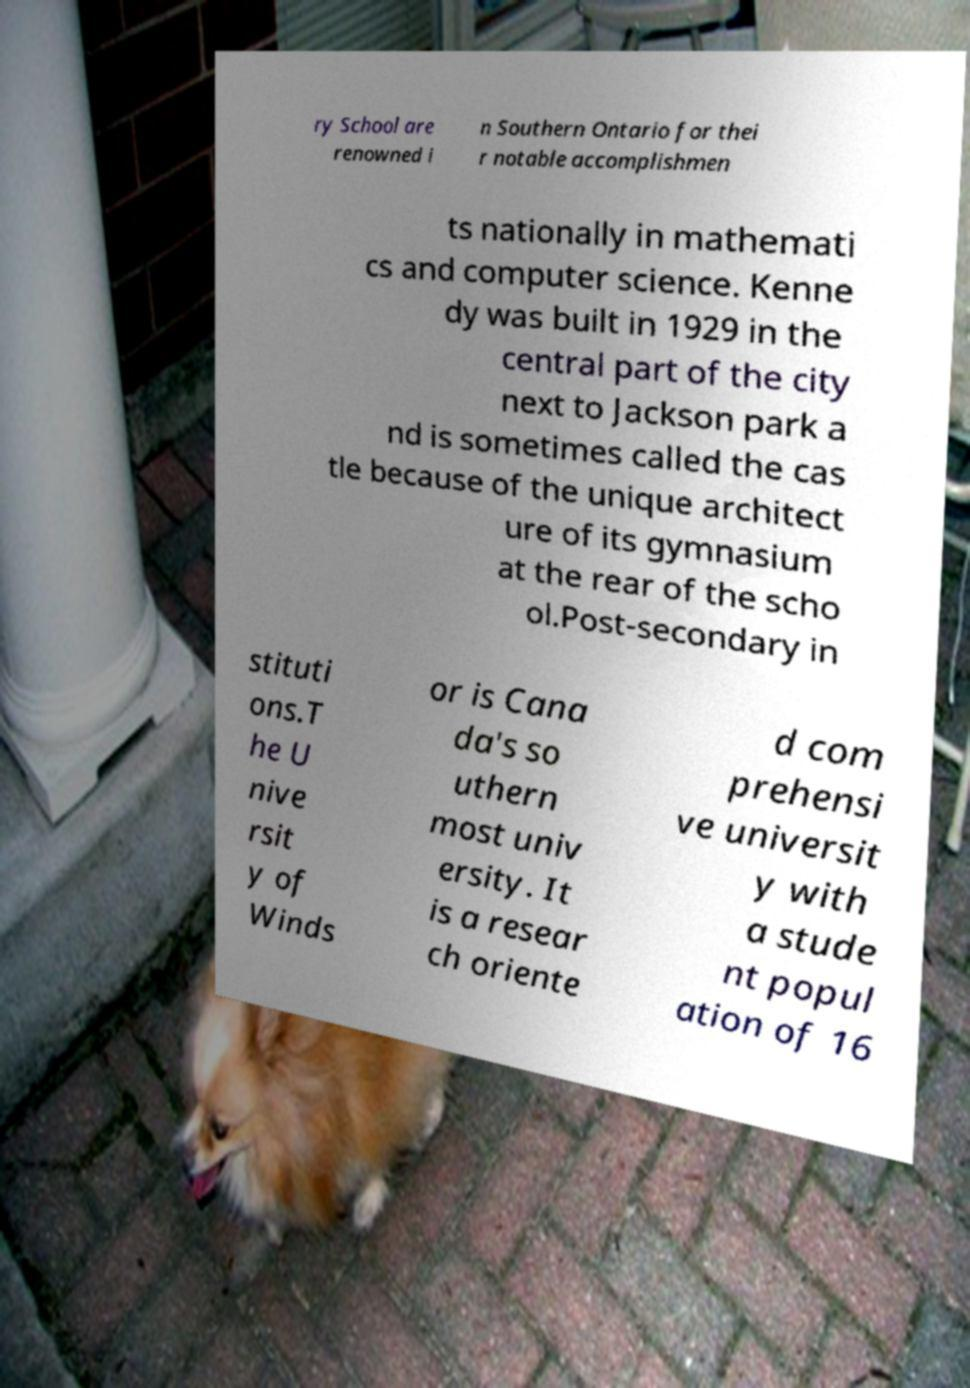Please identify and transcribe the text found in this image. ry School are renowned i n Southern Ontario for thei r notable accomplishmen ts nationally in mathemati cs and computer science. Kenne dy was built in 1929 in the central part of the city next to Jackson park a nd is sometimes called the cas tle because of the unique architect ure of its gymnasium at the rear of the scho ol.Post-secondary in stituti ons.T he U nive rsit y of Winds or is Cana da's so uthern most univ ersity. It is a resear ch oriente d com prehensi ve universit y with a stude nt popul ation of 16 